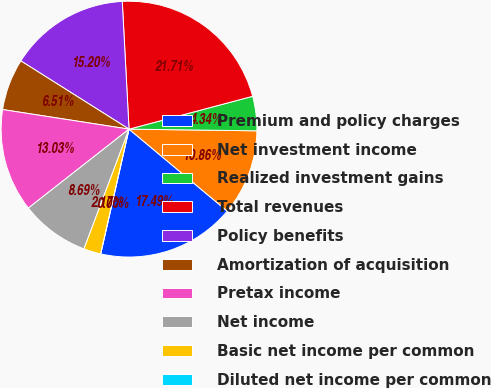Convert chart. <chart><loc_0><loc_0><loc_500><loc_500><pie_chart><fcel>Premium and policy charges<fcel>Net investment income<fcel>Realized investment gains<fcel>Total revenues<fcel>Policy benefits<fcel>Amortization of acquisition<fcel>Pretax income<fcel>Net income<fcel>Basic net income per common<fcel>Diluted net income per common<nl><fcel>17.49%<fcel>10.86%<fcel>4.34%<fcel>21.71%<fcel>15.2%<fcel>6.51%<fcel>13.03%<fcel>8.69%<fcel>2.17%<fcel>0.0%<nl></chart> 